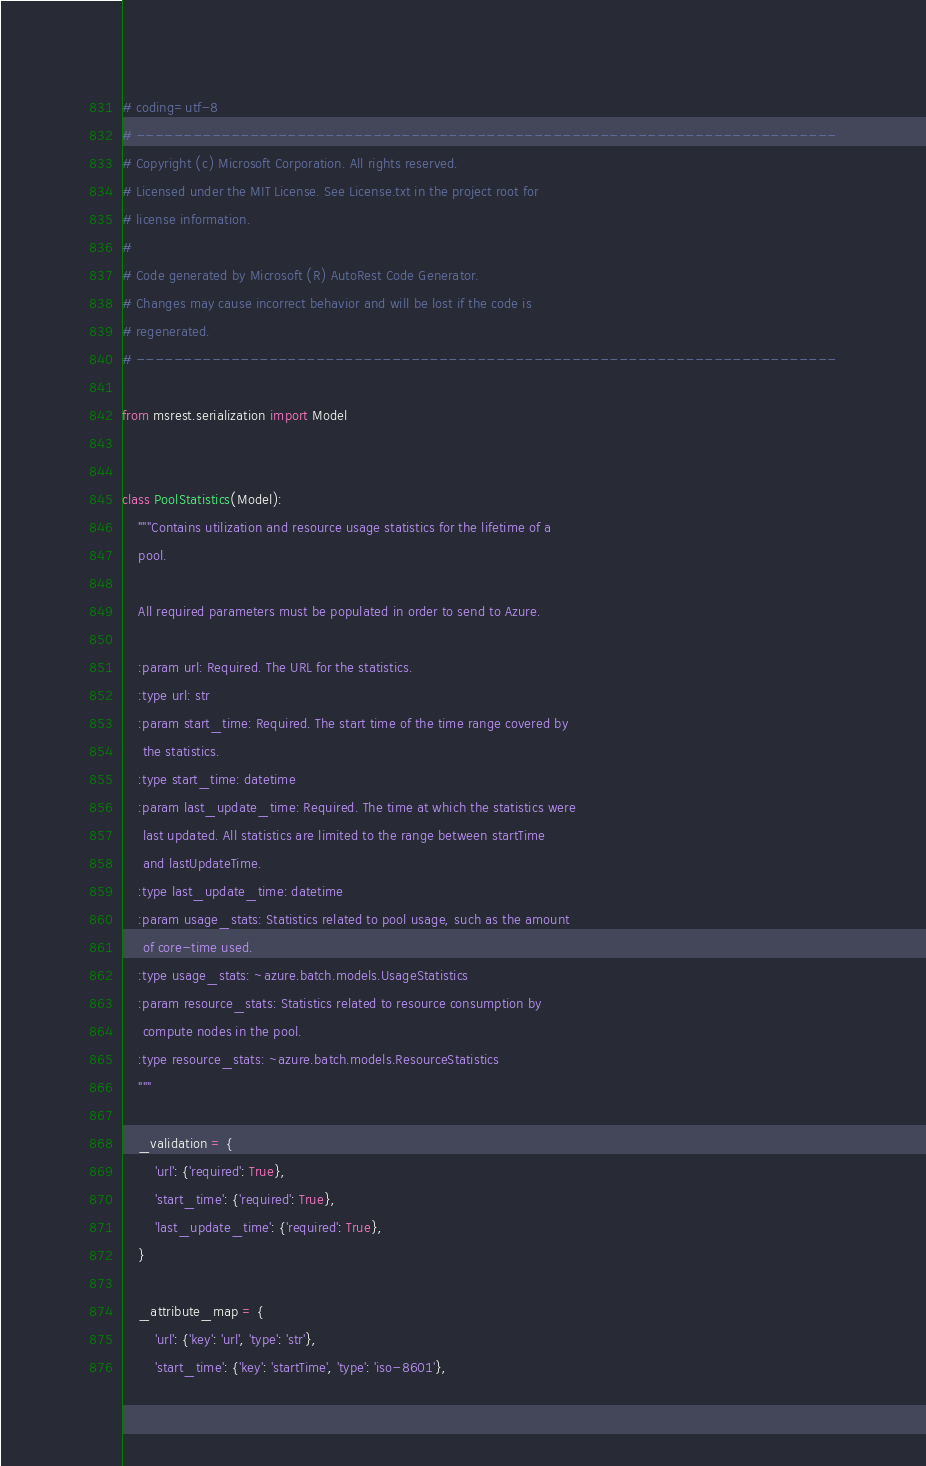<code> <loc_0><loc_0><loc_500><loc_500><_Python_># coding=utf-8
# --------------------------------------------------------------------------
# Copyright (c) Microsoft Corporation. All rights reserved.
# Licensed under the MIT License. See License.txt in the project root for
# license information.
#
# Code generated by Microsoft (R) AutoRest Code Generator.
# Changes may cause incorrect behavior and will be lost if the code is
# regenerated.
# --------------------------------------------------------------------------

from msrest.serialization import Model


class PoolStatistics(Model):
    """Contains utilization and resource usage statistics for the lifetime of a
    pool.

    All required parameters must be populated in order to send to Azure.

    :param url: Required. The URL for the statistics.
    :type url: str
    :param start_time: Required. The start time of the time range covered by
     the statistics.
    :type start_time: datetime
    :param last_update_time: Required. The time at which the statistics were
     last updated. All statistics are limited to the range between startTime
     and lastUpdateTime.
    :type last_update_time: datetime
    :param usage_stats: Statistics related to pool usage, such as the amount
     of core-time used.
    :type usage_stats: ~azure.batch.models.UsageStatistics
    :param resource_stats: Statistics related to resource consumption by
     compute nodes in the pool.
    :type resource_stats: ~azure.batch.models.ResourceStatistics
    """

    _validation = {
        'url': {'required': True},
        'start_time': {'required': True},
        'last_update_time': {'required': True},
    }

    _attribute_map = {
        'url': {'key': 'url', 'type': 'str'},
        'start_time': {'key': 'startTime', 'type': 'iso-8601'},</code> 